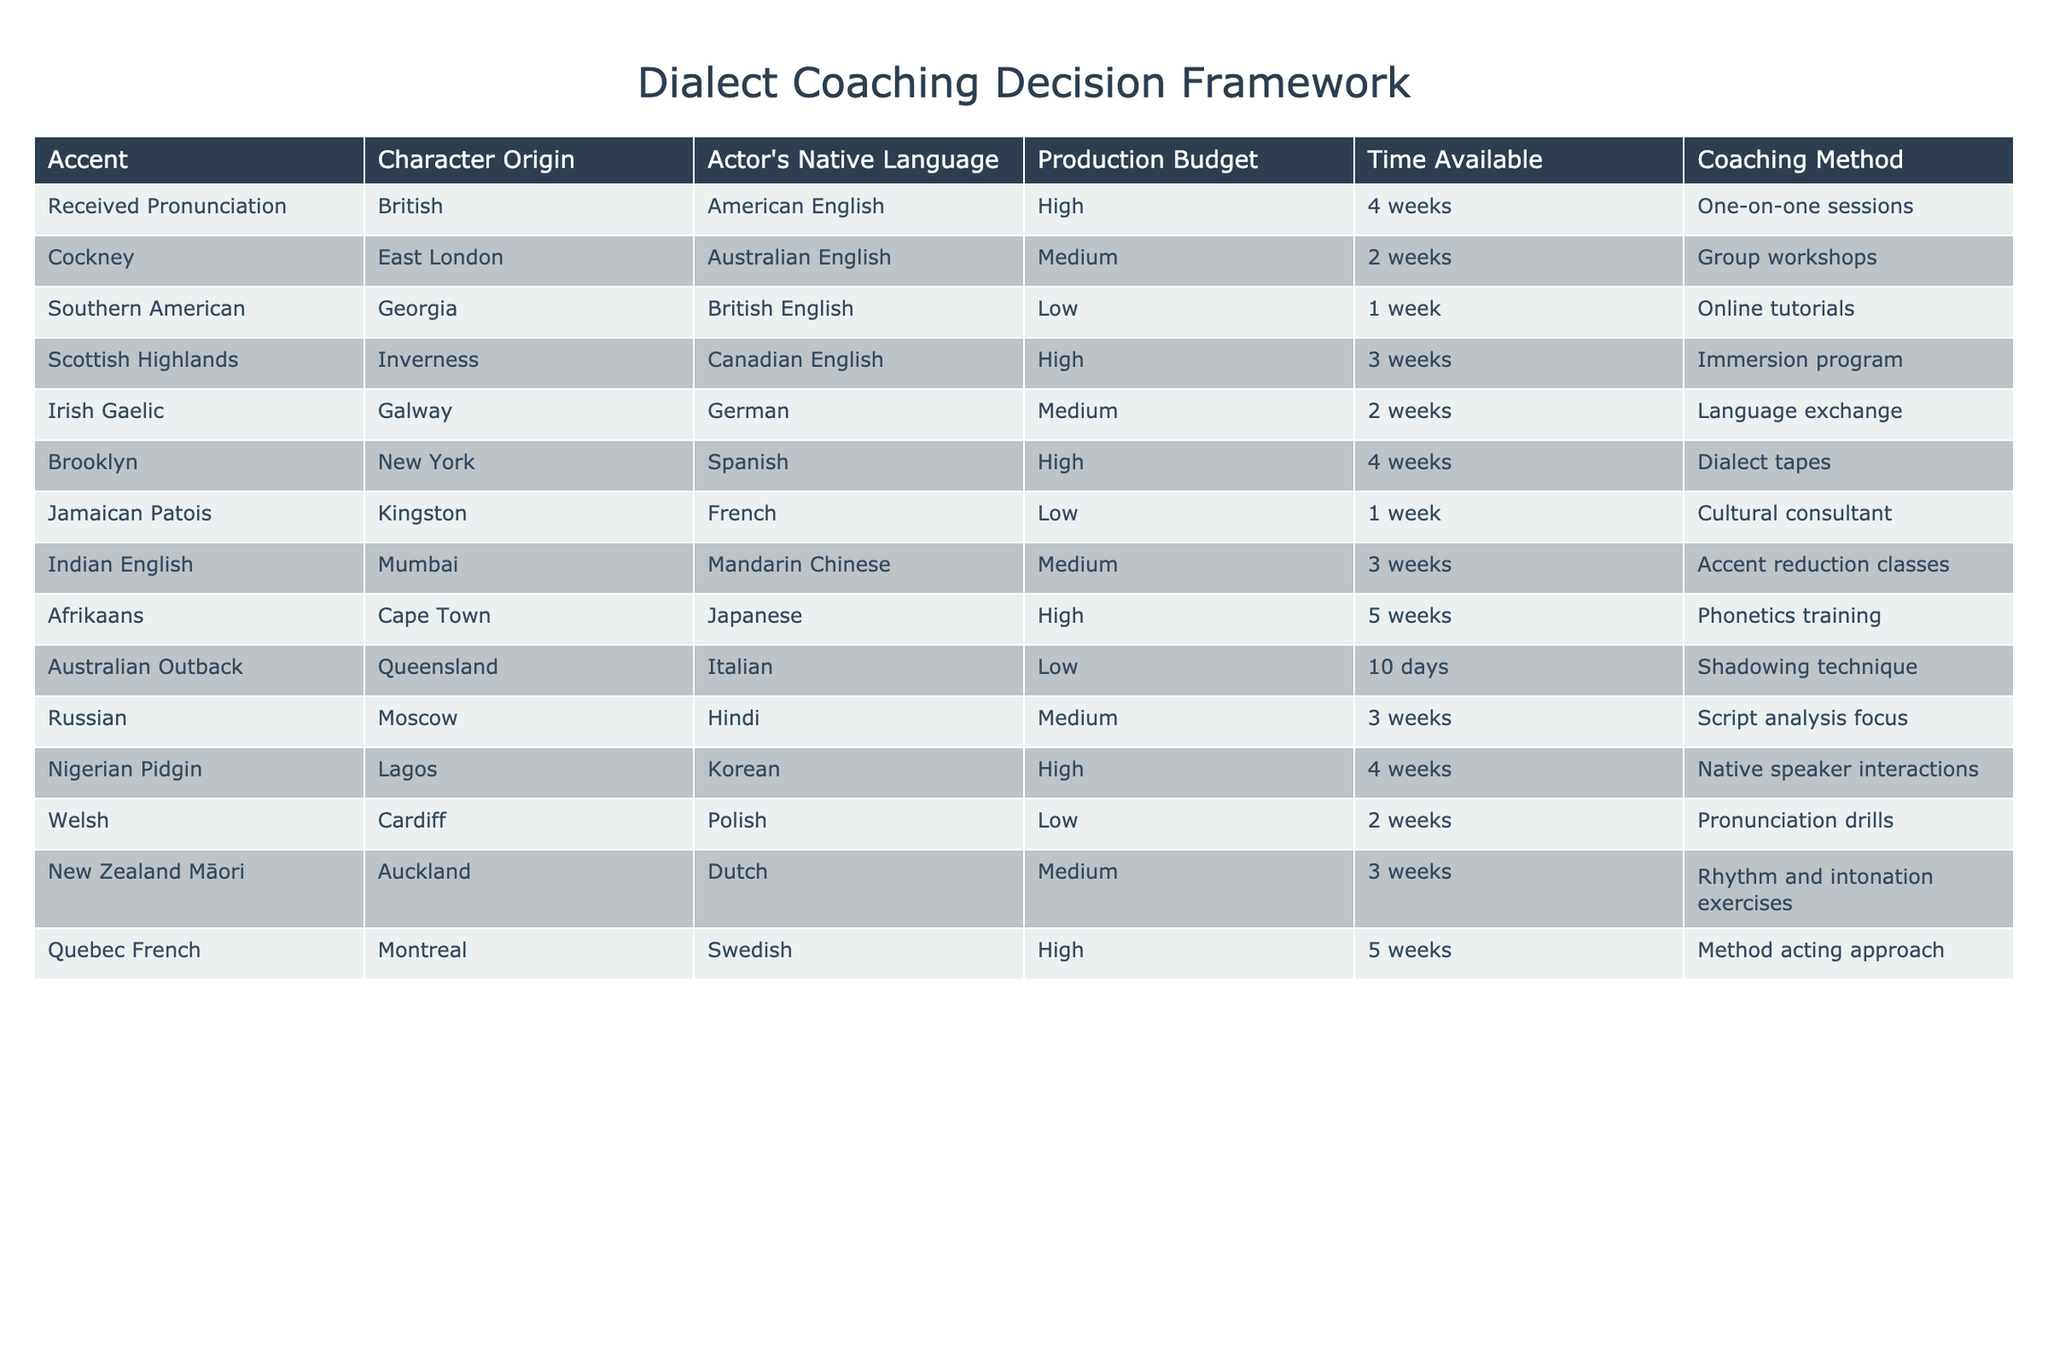What coaching method is used for the Irish Gaelic accent? The table shows that the coaching method for the Irish Gaelic accent is "Language exchange." This can be found directly in the relevant row under the "Coaching Method" column.
Answer: Language exchange Which accent has the highest production budget, and what is the budget level? According to the table, the highest production budget appears for both the Scottish Highlands and Afrikaans accents, categorized as "High." This budget level can be verified by examining the "Production Budget" column for the respective accents.
Answer: Scottish Highlands, High Is the coaching method for Nigerian Pidgin a cultural consultant or dialect tapes? The table indicates that the coaching method for Nigerian Pidgin is "Native speaker interactions," not "Cultural consultant" or "Dialect tapes." Therefore, the statement is false.
Answer: No How many weeks are available for the coaching of the Cockney accent? By looking at the table, we can see that the time available for Cockney coaching is "2 weeks." This information can be found by locating the Cockney row in the "Time Available" column.
Answer: 2 weeks What is the average time available for coaching across all accents listed? To find the average, we add the time values: 4 + 2 + 1 + 3 + 2 + 4 + 1 + 3 + 5 + 10 + 3 + 4 + 2 + 3 = 50 weeks. There are 14 accents, so we divide by 14: 50 / 14 = approximately 3.57 weeks. Hence, the average time available for coaching across all accents is roughly 3.57 weeks.
Answer: 3.57 weeks Which accent has the lowest production budget and what is the respective coaching method? The accents with the lowest budget (indicated as "Low") are Southern American, Jamaican Patois, and Australian Outback. The coaching methods for these are "Online tutorials," "Cultural consultant," and "Shadowing technique" respectively. Among these, we state the Southern American accent as an example.
Answer: Southern American, Online tutorials Does the coaching method for the Afrikaans accent involve phonetics training? The table confirms that the coaching method for the Afrikaans accent is indeed "Phonetics training." Therefore, the statement is true.
Answer: Yes What is the difference in weeks between the lowest and highest time available for coaching? From the table, the lowest time available is "1 week" (for Southern American and Jamaican Patois) and the highest is "10 days" (which is approximately 1.43 weeks for Australian Outback) versus 5 weeks for Afrikaans. The difference between the lowest time (1 week) and highest (5 weeks) is 5 - 1 = 4 weeks.
Answer: 4 weeks 